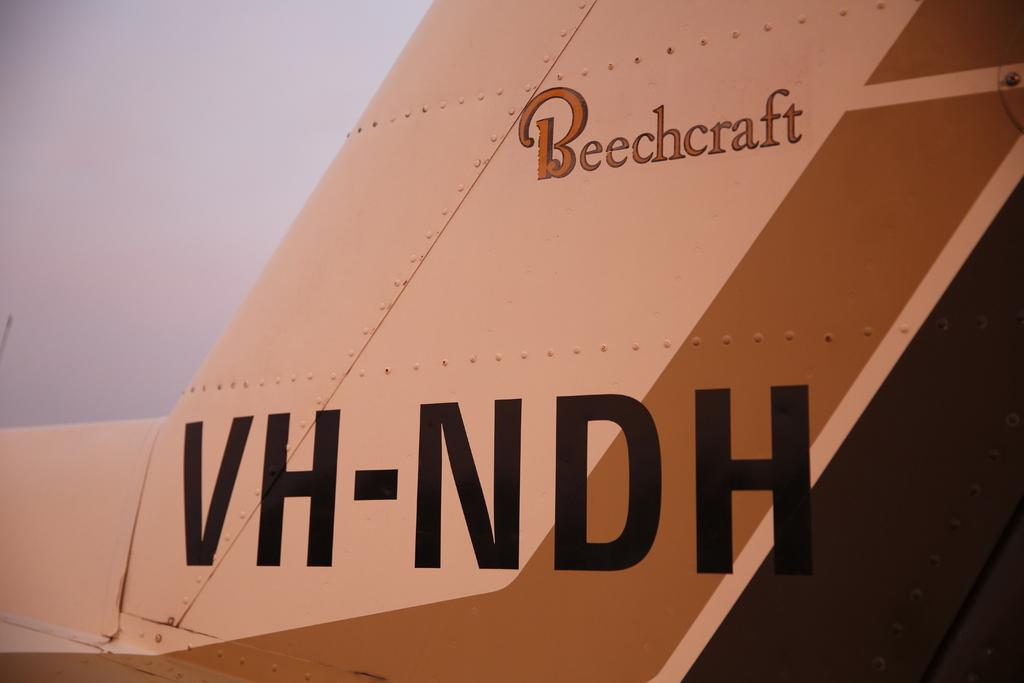<image>
Render a clear and concise summary of the photo. The tail of a Beechcraft airplane has the identifier VH-NDH on it. 